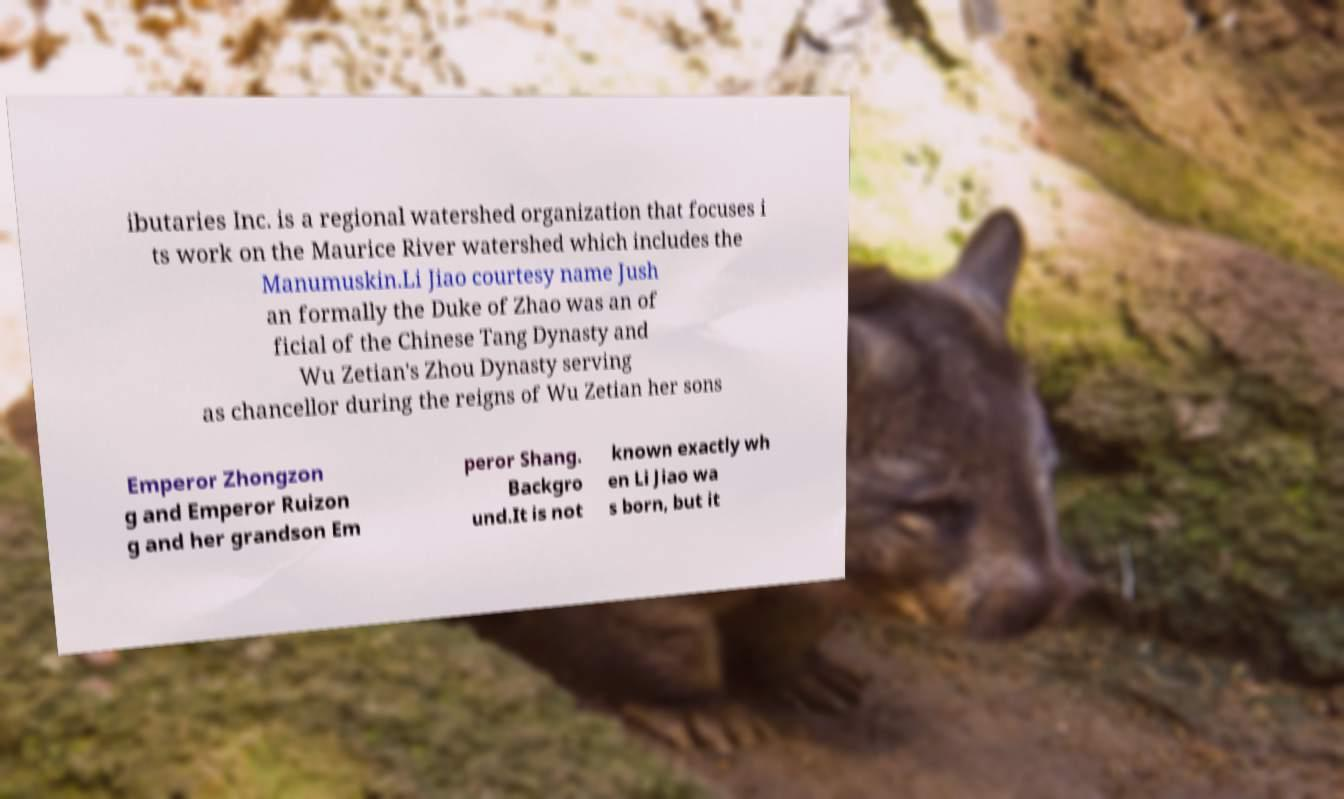Could you extract and type out the text from this image? ibutaries Inc. is a regional watershed organization that focuses i ts work on the Maurice River watershed which includes the Manumuskin.Li Jiao courtesy name Jush an formally the Duke of Zhao was an of ficial of the Chinese Tang Dynasty and Wu Zetian's Zhou Dynasty serving as chancellor during the reigns of Wu Zetian her sons Emperor Zhongzon g and Emperor Ruizon g and her grandson Em peror Shang. Backgro und.It is not known exactly wh en Li Jiao wa s born, but it 